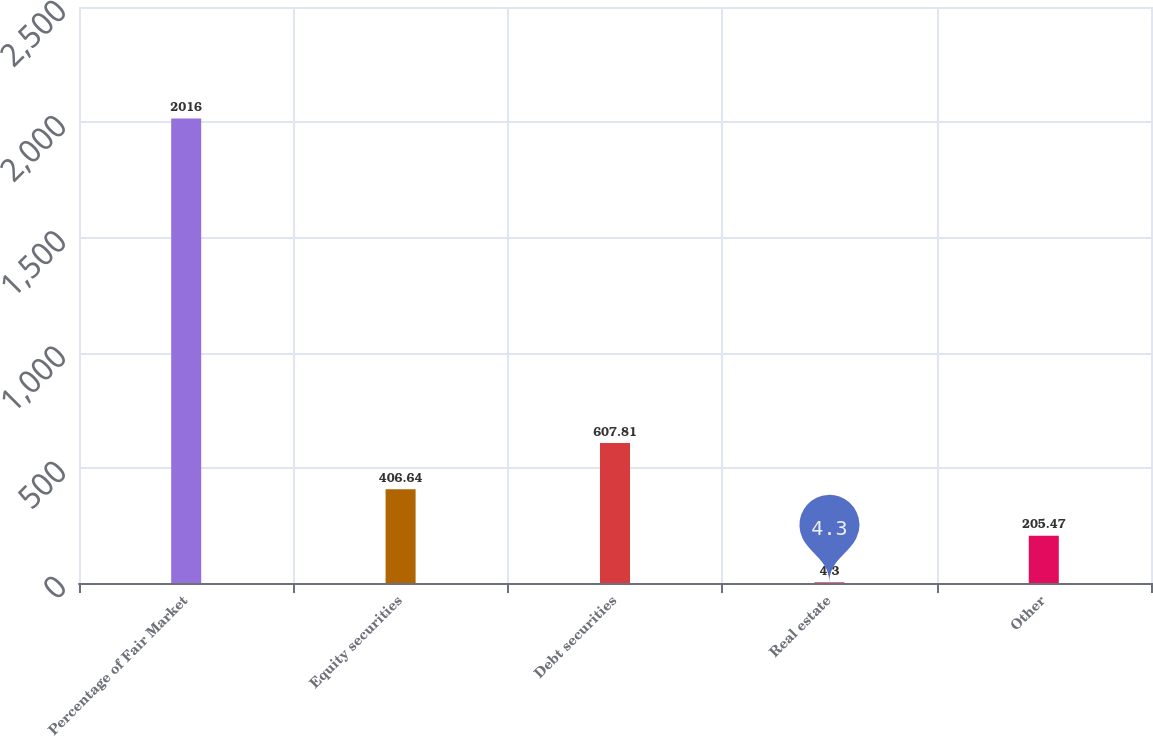Convert chart to OTSL. <chart><loc_0><loc_0><loc_500><loc_500><bar_chart><fcel>Percentage of Fair Market<fcel>Equity securities<fcel>Debt securities<fcel>Real estate<fcel>Other<nl><fcel>2016<fcel>406.64<fcel>607.81<fcel>4.3<fcel>205.47<nl></chart> 